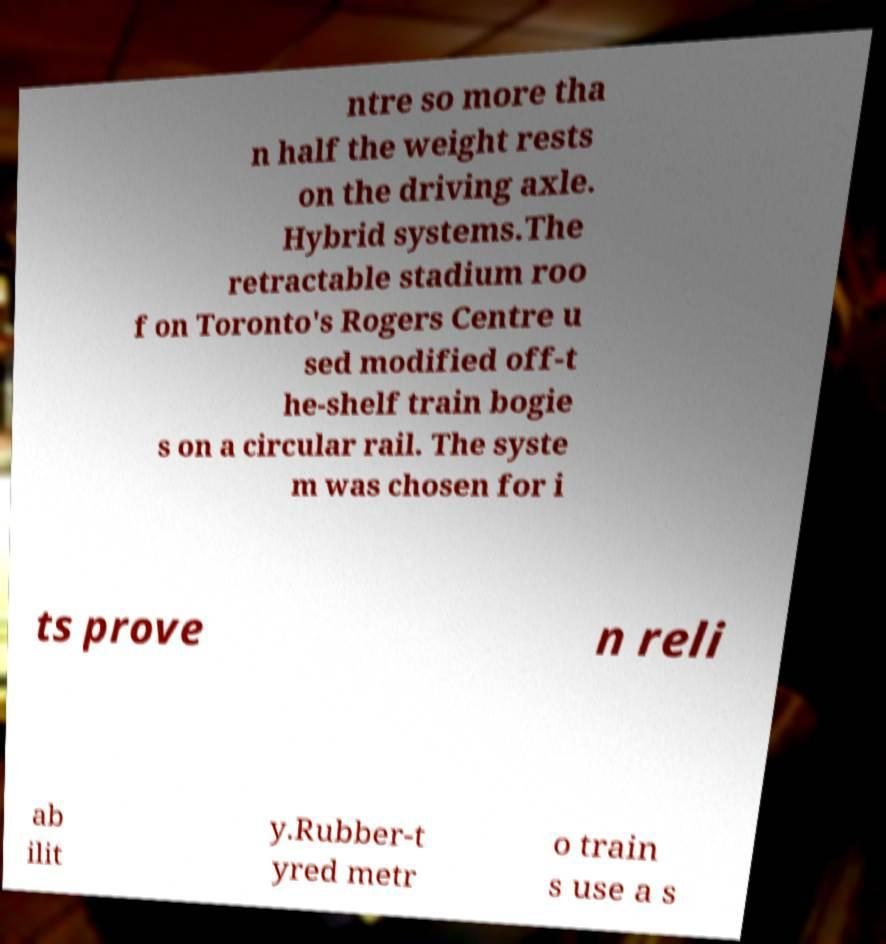Can you read and provide the text displayed in the image?This photo seems to have some interesting text. Can you extract and type it out for me? ntre so more tha n half the weight rests on the driving axle. Hybrid systems.The retractable stadium roo f on Toronto's Rogers Centre u sed modified off-t he-shelf train bogie s on a circular rail. The syste m was chosen for i ts prove n reli ab ilit y.Rubber-t yred metr o train s use a s 